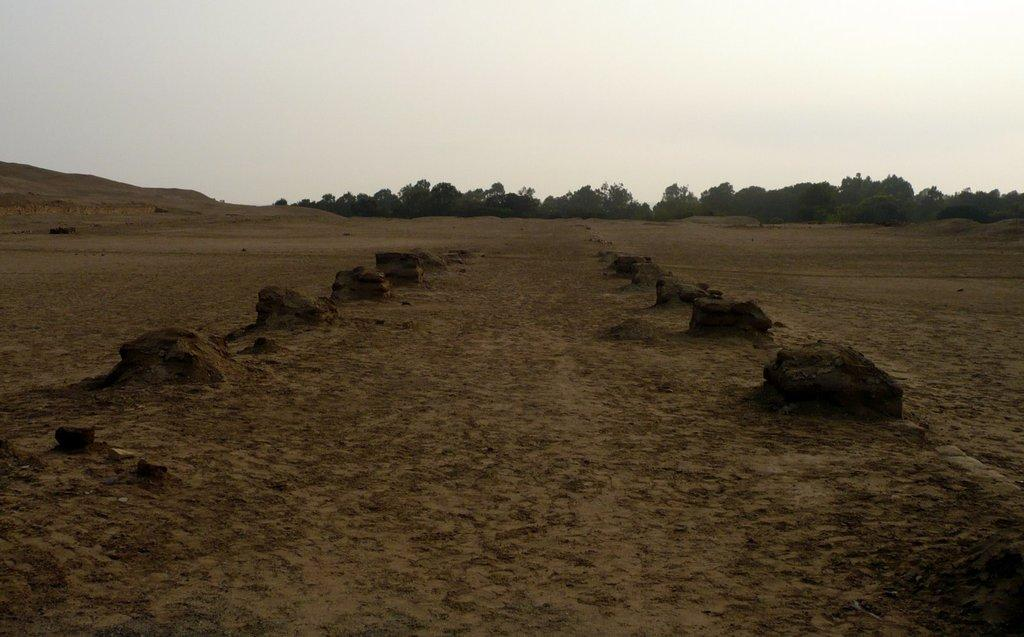What type of natural elements can be seen on the ground in the image? There are stones on the ground in the image. What other natural elements are present in the image? There are trees in the image. What can be seen in the background of the image? The sky is visible in the background of the image. Can you tell me how many combs are used to maintain the trees in the image? There are no combs present in the image, and combs are not used to maintain trees. What type of vegetable is being grown in the image? There is no vegetable, such as cabbage, being grown in the image. 